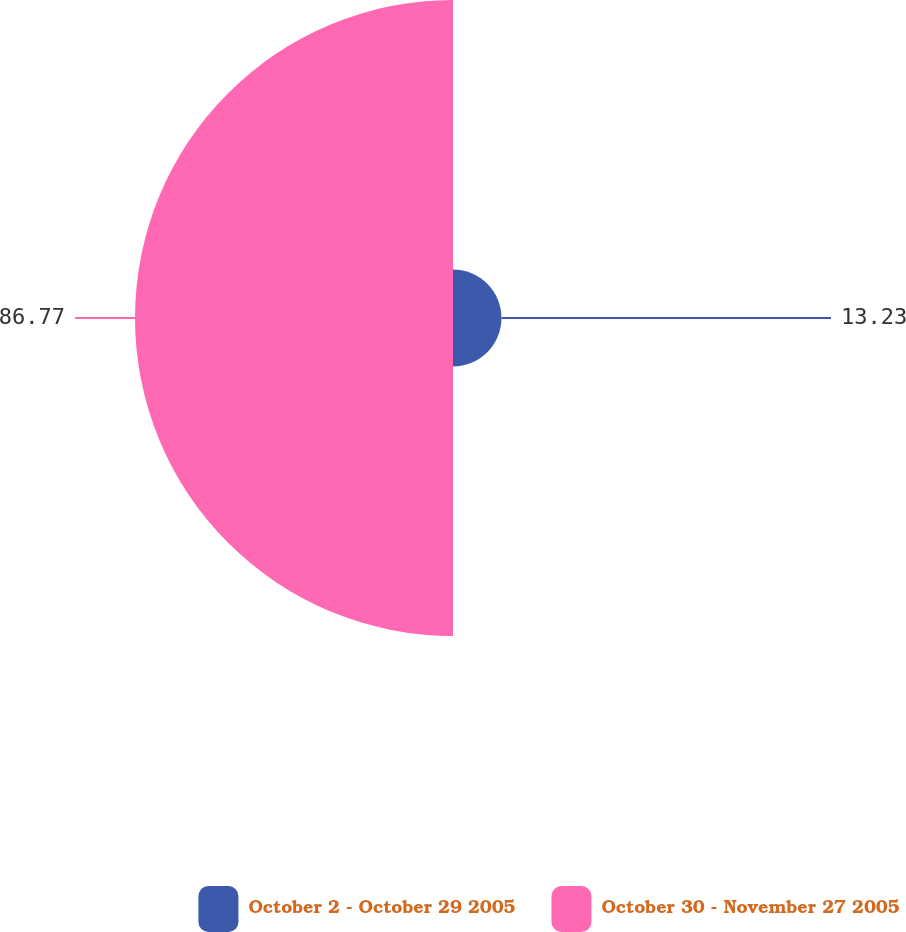Convert chart to OTSL. <chart><loc_0><loc_0><loc_500><loc_500><pie_chart><fcel>October 2 - October 29 2005<fcel>October 30 - November 27 2005<nl><fcel>13.23%<fcel>86.77%<nl></chart> 